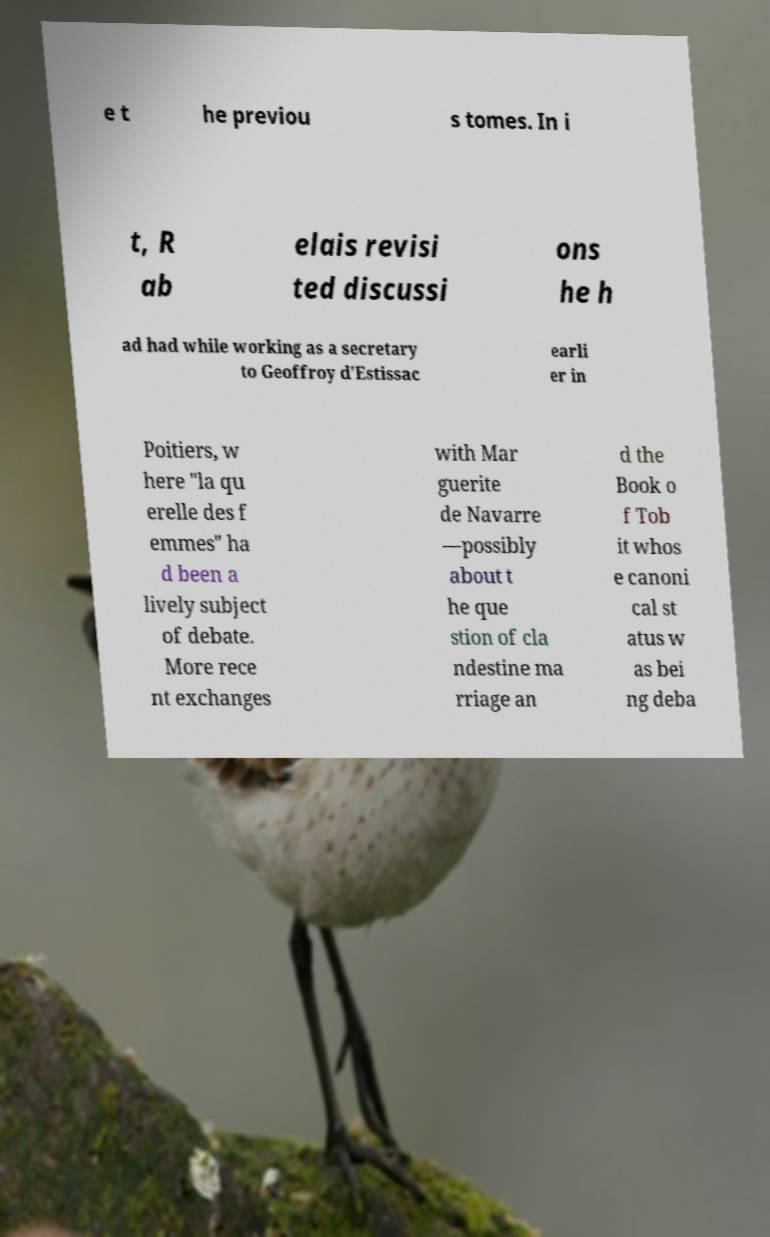For documentation purposes, I need the text within this image transcribed. Could you provide that? e t he previou s tomes. In i t, R ab elais revisi ted discussi ons he h ad had while working as a secretary to Geoffroy d'Estissac earli er in Poitiers, w here "la qu erelle des f emmes" ha d been a lively subject of debate. More rece nt exchanges with Mar guerite de Navarre —possibly about t he que stion of cla ndestine ma rriage an d the Book o f Tob it whos e canoni cal st atus w as bei ng deba 